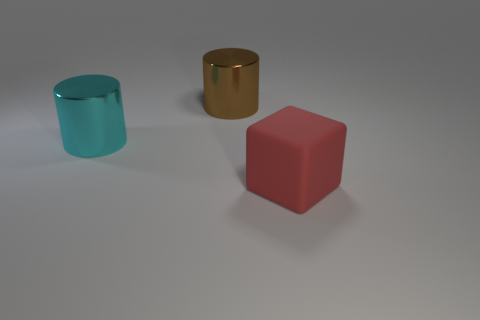The thing that is both in front of the brown metallic cylinder and to the right of the cyan cylinder is made of what material?
Give a very brief answer. Rubber. Are there any red things that have the same size as the red cube?
Offer a very short reply. No. What material is the red block that is the same size as the cyan metal cylinder?
Give a very brief answer. Rubber. There is a brown cylinder; what number of matte objects are in front of it?
Your response must be concise. 1. Do the big shiny object that is behind the large cyan metallic thing and the cyan metallic object have the same shape?
Offer a terse response. Yes. Are there any brown metallic things of the same shape as the large cyan shiny object?
Provide a short and direct response. Yes. There is a shiny thing right of the large metal cylinder on the left side of the big brown object; what is its shape?
Your answer should be compact. Cylinder. What number of green blocks are the same material as the brown cylinder?
Your answer should be very brief. 0. There is a cylinder that is made of the same material as the brown thing; what is its color?
Give a very brief answer. Cyan. There is a metallic cylinder that is to the right of the large thing that is on the left side of the large thing that is behind the cyan metallic object; what size is it?
Your response must be concise. Large. 